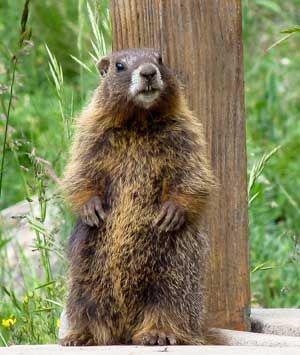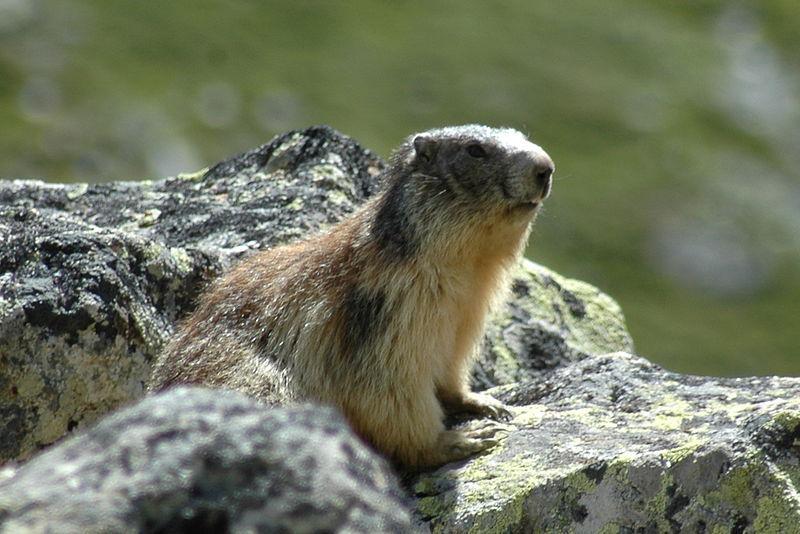The first image is the image on the left, the second image is the image on the right. Considering the images on both sides, is "In one of the images there is an animal facing right." valid? Answer yes or no. Yes. 